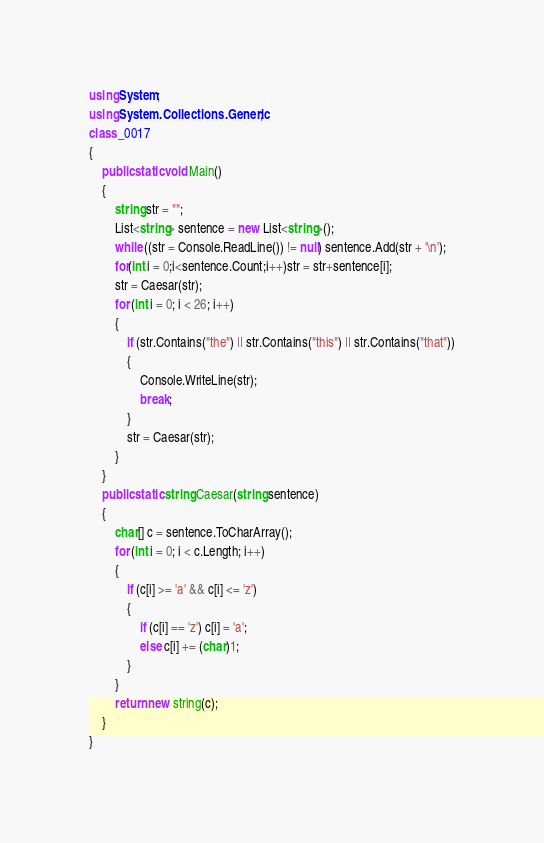Convert code to text. <code><loc_0><loc_0><loc_500><loc_500><_C#_>using System;
using System.Collections.Generic;
class _0017
{
    public static void Main()
    {
        string str = "";
        List<string> sentence = new List<string>();
        while ((str = Console.ReadLine()) != null) sentence.Add(str + '\n');
        for(int i = 0;i<sentence.Count;i++)str = str+sentence[i];
        str = Caesar(str);
        for (int i = 0; i < 26; i++)
        {
            if (str.Contains("the") || str.Contains("this") || str.Contains("that"))
            {
                Console.WriteLine(str);
                break;
            }
            str = Caesar(str);
        }
    }
    public static string Caesar(string sentence)
    {
        char[] c = sentence.ToCharArray();
        for (int i = 0; i < c.Length; i++)
        {
            if (c[i] >= 'a' && c[i] <= 'z')
            {
                if (c[i] == 'z') c[i] = 'a';
                else c[i] += (char)1;
            }
        }
        return new string(c);
    }
}</code> 